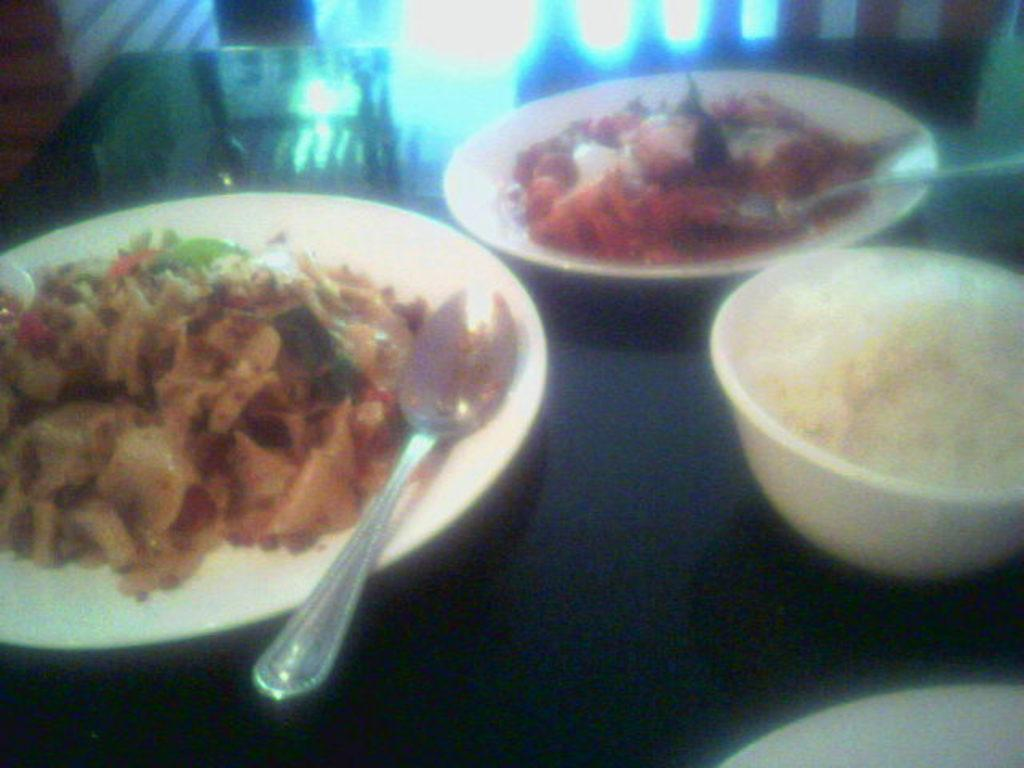What is the main piece of furniture in the image? There is a table in the image. What can be found on the table? There are food items on two plates on the table, spoons, and a bowl. How many plates are there on the table? There are two plates on the table. What type of toothpaste is being used by the beast in the image? There is no toothpaste or beast present in the image. Is the actor in the image using the spoon to eat the food? There is no actor present in the image; it only shows a table with food items, spoons, and a bowl. 